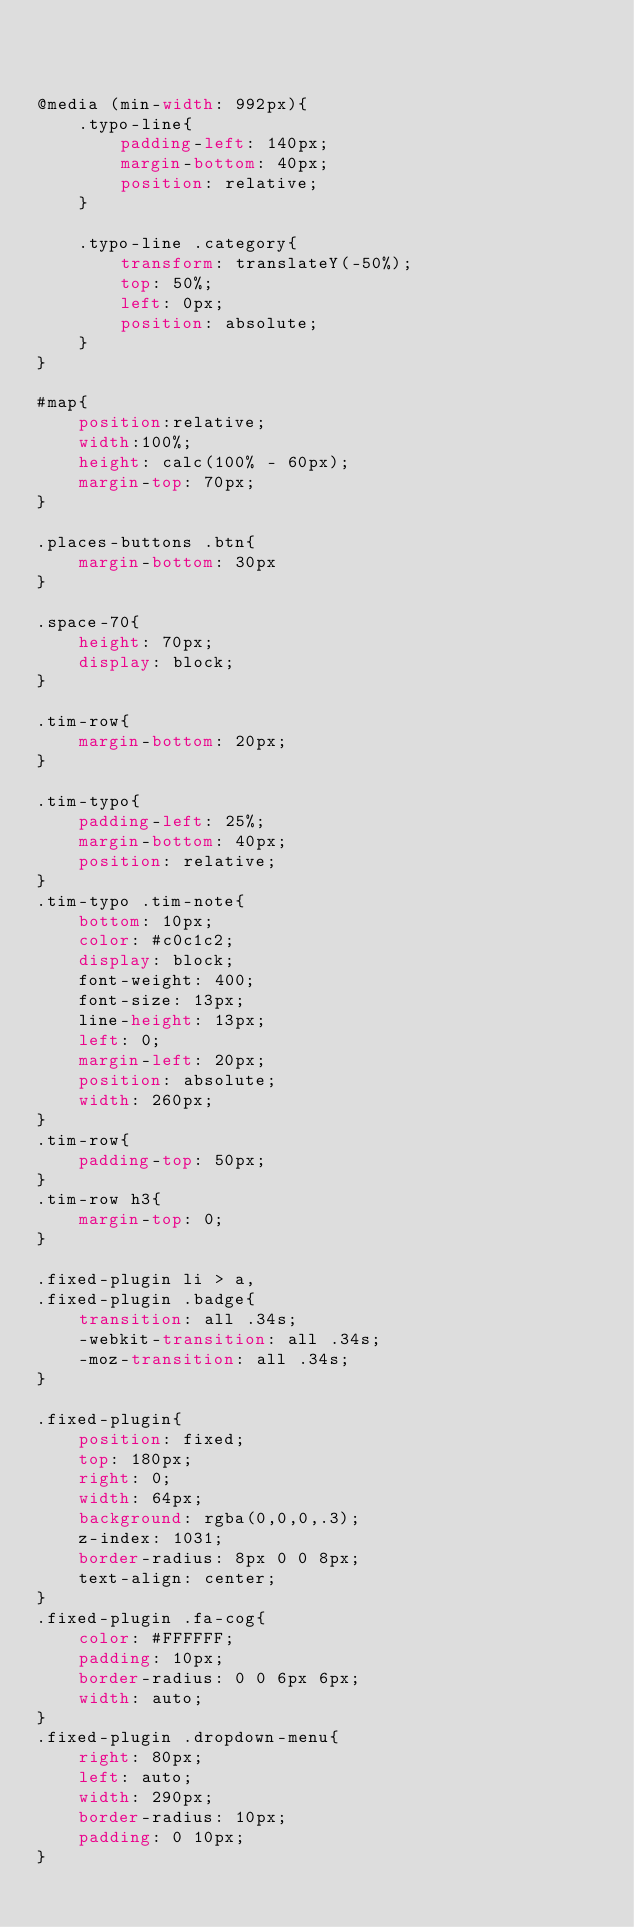Convert code to text. <code><loc_0><loc_0><loc_500><loc_500><_CSS_>


@media (min-width: 992px){
    .typo-line{
        padding-left: 140px;
        margin-bottom: 40px;
        position: relative;
    }

    .typo-line .category{
        transform: translateY(-50%);
        top: 50%;
        left: 0px;
        position: absolute;
    }
}

#map{
    position:relative;
    width:100%;
    height: calc(100% - 60px);
    margin-top: 70px;
}

.places-buttons .btn{
    margin-bottom: 30px
}

.space-70{
    height: 70px;
    display: block;
}

.tim-row{
    margin-bottom: 20px;
}

.tim-typo{
    padding-left: 25%;
    margin-bottom: 40px;
    position: relative;
}
.tim-typo .tim-note{
    bottom: 10px;
    color: #c0c1c2;
    display: block;
    font-weight: 400;
    font-size: 13px;
    line-height: 13px;
    left: 0;
    margin-left: 20px;
    position: absolute;
    width: 260px;
}
.tim-row{
    padding-top: 50px;
}
.tim-row h3{
    margin-top: 0;
}

.fixed-plugin li > a,
.fixed-plugin .badge{
    transition: all .34s;
    -webkit-transition: all .34s;
    -moz-transition: all .34s;
}

.fixed-plugin{
    position: fixed;
    top: 180px;
    right: 0;
    width: 64px;
    background: rgba(0,0,0,.3);
    z-index: 1031;
    border-radius: 8px 0 0 8px;
    text-align: center;
}
.fixed-plugin .fa-cog{
    color: #FFFFFF;
    padding: 10px;
    border-radius: 0 0 6px 6px;
    width: auto;
}
.fixed-plugin .dropdown-menu{
    right: 80px;
    left: auto;
    width: 290px;
    border-radius: 10px;
    padding: 0 10px;
}</code> 